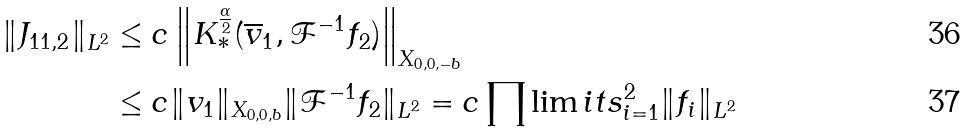<formula> <loc_0><loc_0><loc_500><loc_500>\| J _ { 1 1 , 2 } \| _ { L ^ { 2 } } & \leq c \left \| K ^ { \frac { \alpha } { 2 } } _ { \ast } ( \overline { v } _ { 1 } , \mathcal { F } ^ { - 1 } f _ { 2 } ) \right \| _ { X _ { 0 , 0 , - b } } \\ & \leq c \| v _ { 1 } \| _ { X _ { 0 , 0 , b } } \| \mathcal { F } ^ { - 1 } f _ { 2 } \| _ { L ^ { 2 } } = c \prod \lim i t s _ { i = 1 } ^ { 2 } \| f _ { i } \| _ { L ^ { 2 } }</formula> 